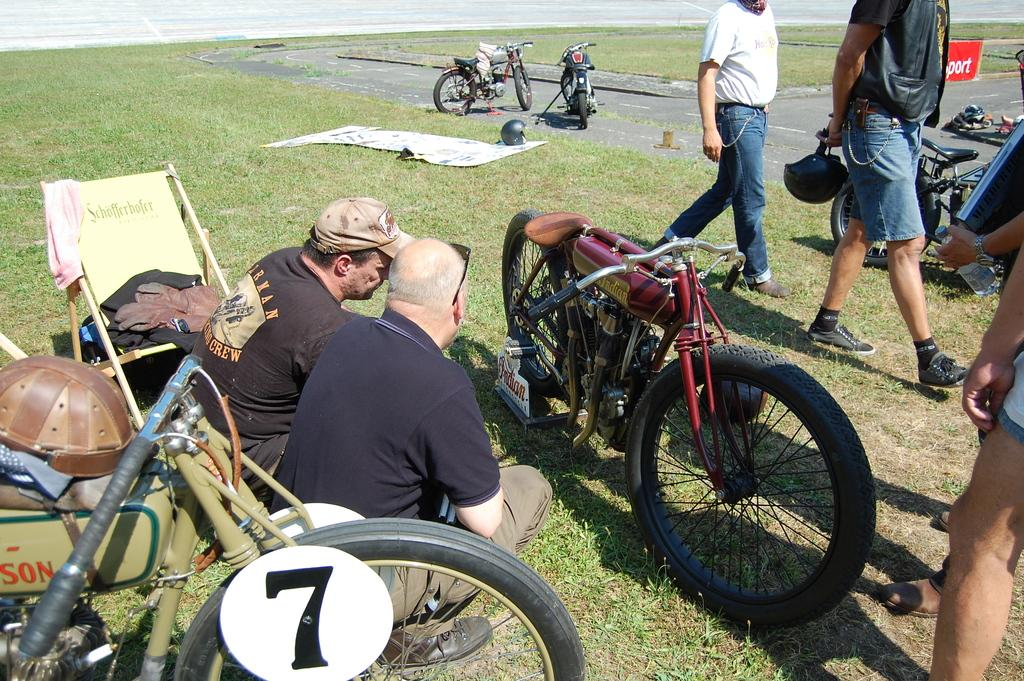What type of vehicles are in the image? There are bikes in the image. Where are the bikes located? The bikes are on a ground. What are the people in the image doing? There are two persons sitting on the ground, and three persons standing in the image. Can you describe any furniture in the image? There is at least one chair in the image. What type of shade is provided by the trucks in the image? There are no trucks present in the image, so no shade is provided by trucks. 